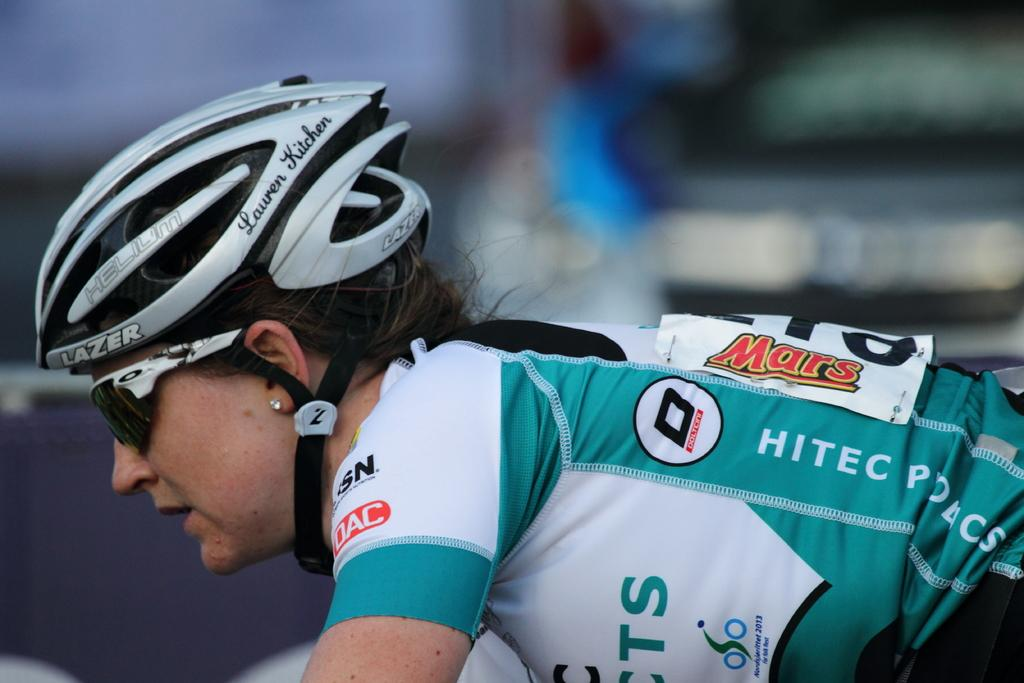Who is the main subject in the image? There is a woman in the image. What is the woman wearing on her head? The woman is wearing a helmet. What color is the woman's jersey? The woman is wearing a green color jersey. Can you describe the background of the image? The background of the image is blurred. What type of eyewear is the woman wearing? The woman is wearing shades. What type of underwear is the woman wearing in the image? There is no information about the woman's underwear in the image, so we cannot determine what type she is wearing. What type of print can be seen on the woman's jersey? The woman's jersey is described as green, but there is no mention of any print on it. 